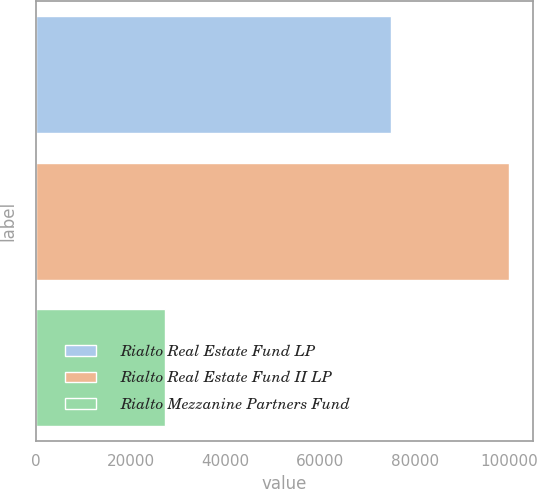Convert chart. <chart><loc_0><loc_0><loc_500><loc_500><bar_chart><fcel>Rialto Real Estate Fund LP<fcel>Rialto Real Estate Fund II LP<fcel>Rialto Mezzanine Partners Fund<nl><fcel>75000<fcel>100000<fcel>27299<nl></chart> 